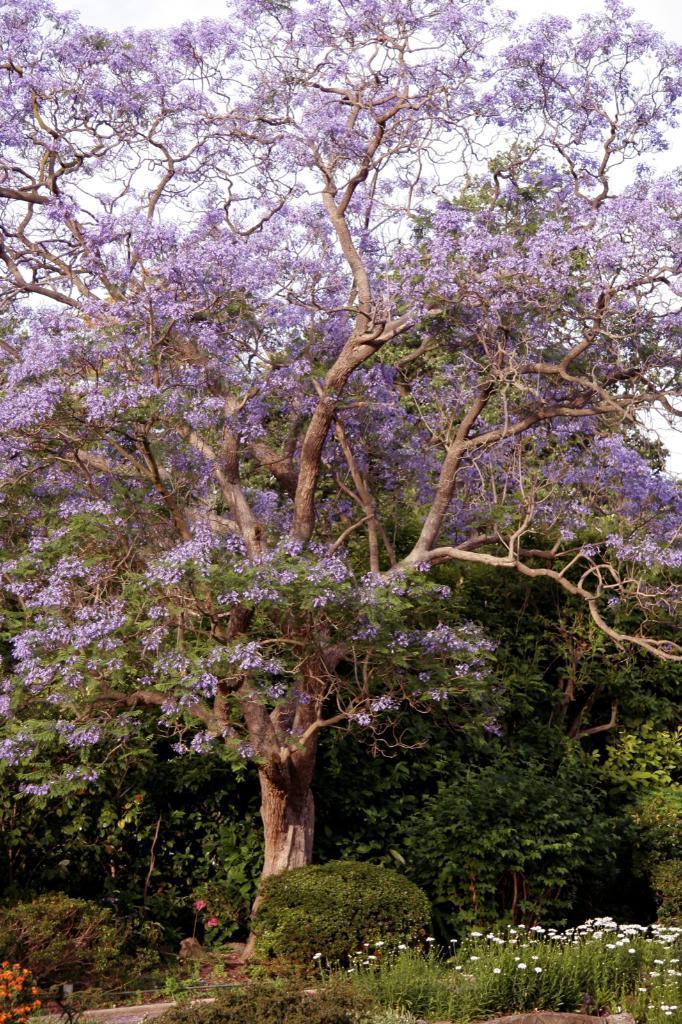In one or two sentences, can you explain what this image depicts? In the image we can see some trees and plants and flowers. Behind the tree there is sky. 